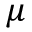Convert formula to latex. <formula><loc_0><loc_0><loc_500><loc_500>\mu</formula> 